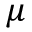Convert formula to latex. <formula><loc_0><loc_0><loc_500><loc_500>\mu</formula> 